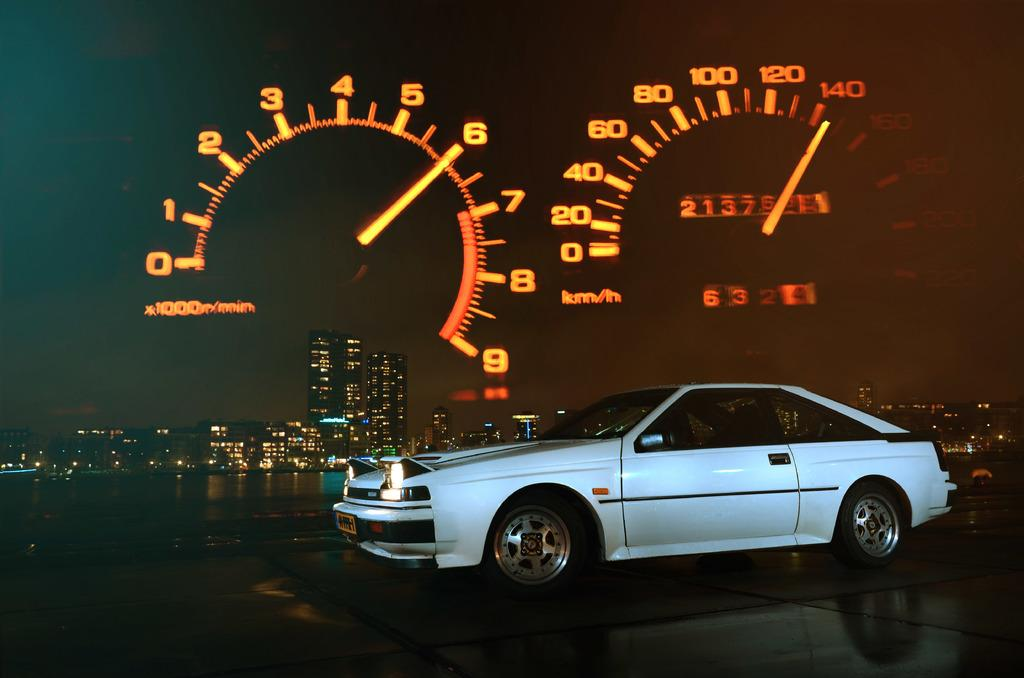What is the main subject of the image? The main subject of the image is a car. What can be seen in the image besides the car? There is water, trees, lights, and the sky visible in the image. What feature of the car is visible in the image? There is a speed meter in the image. What type of error can be seen on the car's dashboard in the image? There is no error visible on the car's dashboard in the image. What type of milk is being poured into the water in the image? There is no milk or pouring action present in the image. 